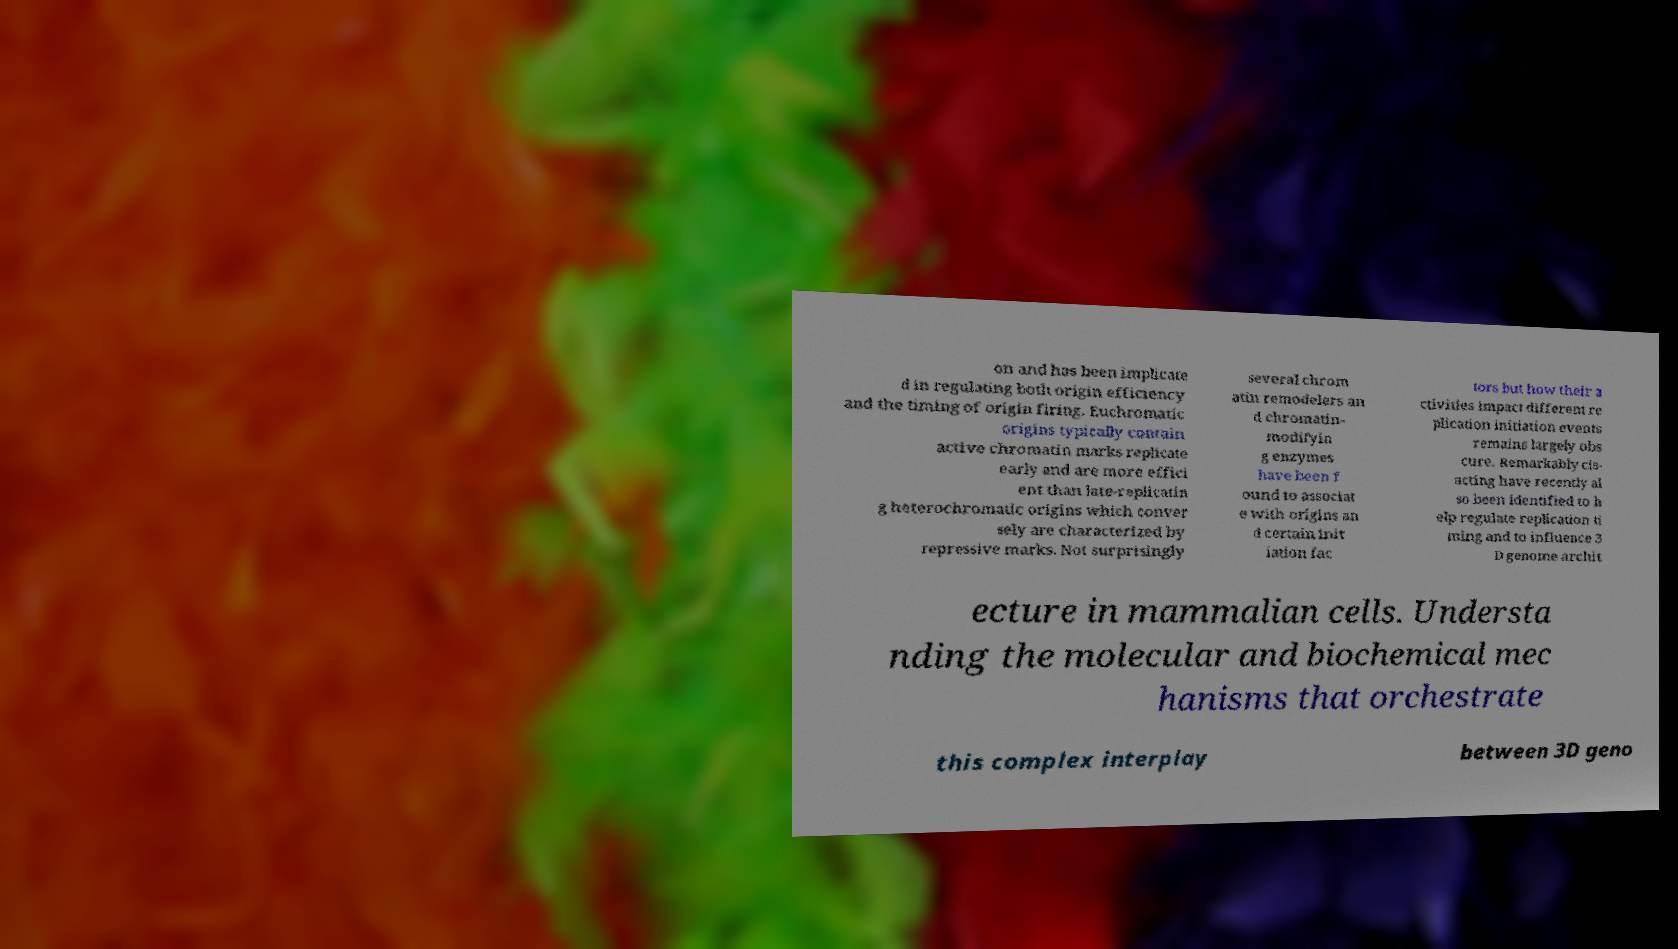What messages or text are displayed in this image? I need them in a readable, typed format. on and has been implicate d in regulating both origin efficiency and the timing of origin firing. Euchromatic origins typically contain active chromatin marks replicate early and are more effici ent than late-replicatin g heterochromatic origins which conver sely are characterized by repressive marks. Not surprisingly several chrom atin remodelers an d chromatin- modifyin g enzymes have been f ound to associat e with origins an d certain init iation fac tors but how their a ctivities impact different re plication initiation events remains largely obs cure. Remarkably cis- acting have recently al so been identified to h elp regulate replication ti ming and to influence 3 D genome archit ecture in mammalian cells. Understa nding the molecular and biochemical mec hanisms that orchestrate this complex interplay between 3D geno 